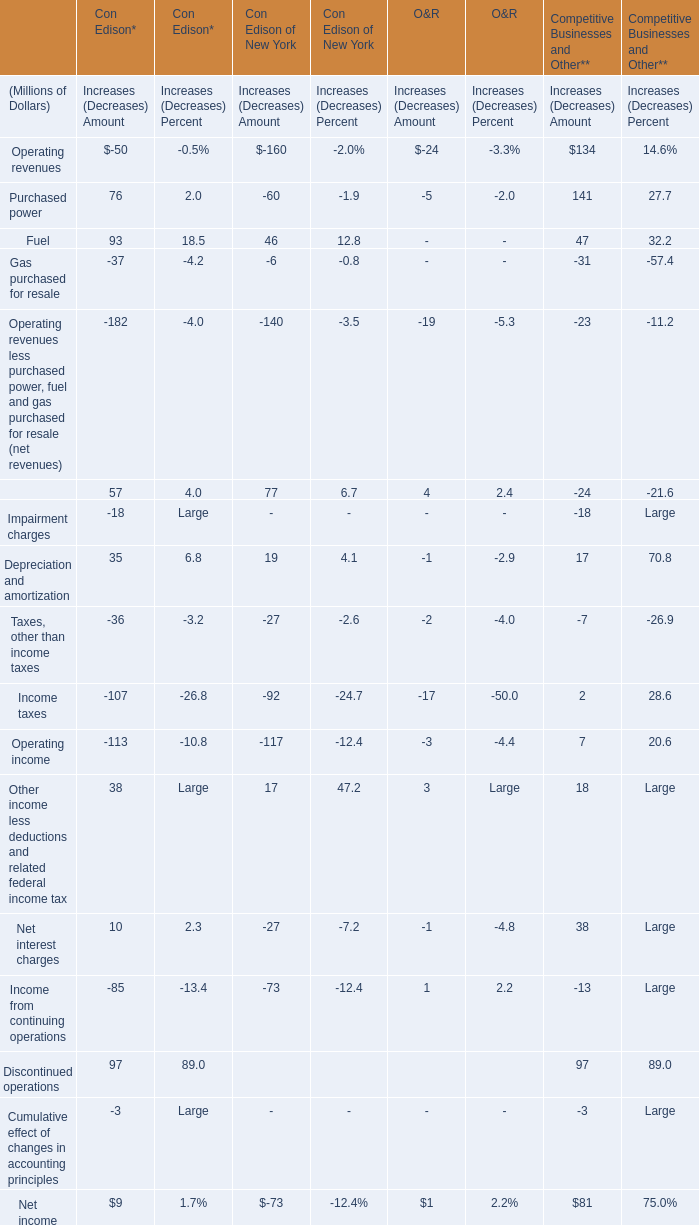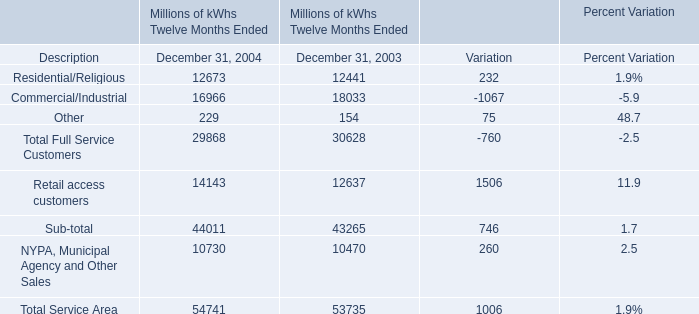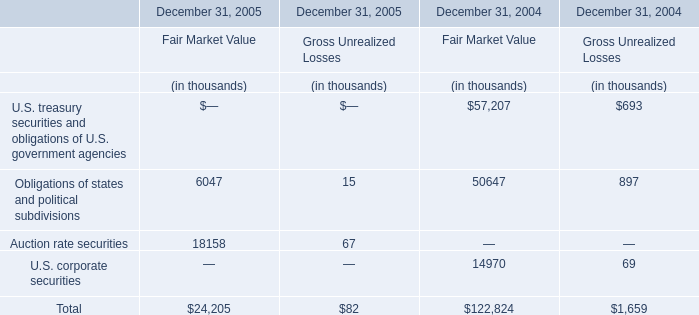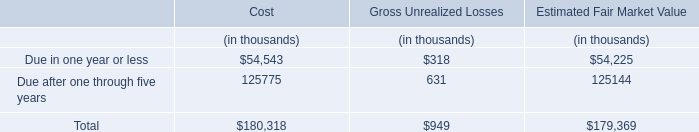What is the average value for Total Full Service Customers, Retail access customers, and NYPA, Municipal Agency and Other Sales in 2004? (in millions) 
Computations: (54741 / 3)
Answer: 18247.0. 